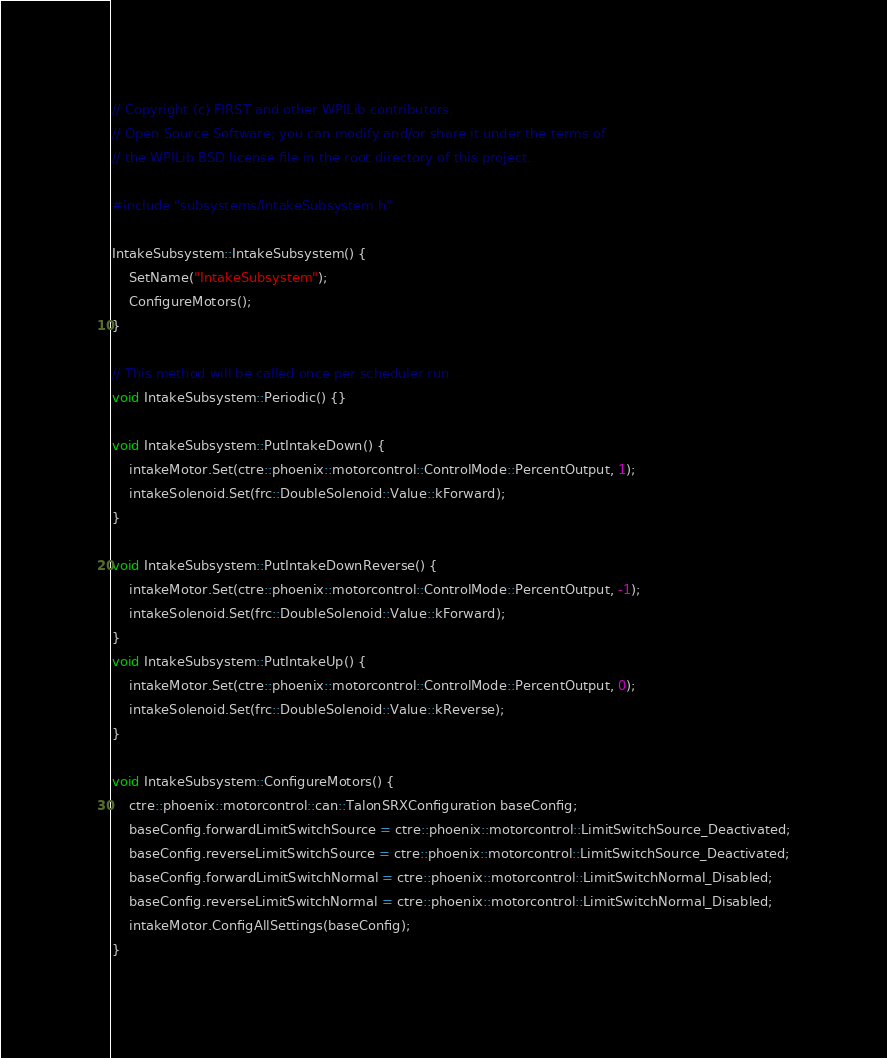Convert code to text. <code><loc_0><loc_0><loc_500><loc_500><_C++_>// Copyright (c) FIRST and other WPILib contributors.
// Open Source Software; you can modify and/or share it under the terms of
// the WPILib BSD license file in the root directory of this project.

#include "subsystems/IntakeSubsystem.h"

IntakeSubsystem::IntakeSubsystem() {
    SetName("IntakeSubsystem");
    ConfigureMotors();
}

// This method will be called once per scheduler run
void IntakeSubsystem::Periodic() {}

void IntakeSubsystem::PutIntakeDown() {
    intakeMotor.Set(ctre::phoenix::motorcontrol::ControlMode::PercentOutput, 1);
    intakeSolenoid.Set(frc::DoubleSolenoid::Value::kForward);
}

void IntakeSubsystem::PutIntakeDownReverse() {
    intakeMotor.Set(ctre::phoenix::motorcontrol::ControlMode::PercentOutput, -1);
    intakeSolenoid.Set(frc::DoubleSolenoid::Value::kForward);
}
void IntakeSubsystem::PutIntakeUp() {
    intakeMotor.Set(ctre::phoenix::motorcontrol::ControlMode::PercentOutput, 0);
    intakeSolenoid.Set(frc::DoubleSolenoid::Value::kReverse);
}

void IntakeSubsystem::ConfigureMotors() {
    ctre::phoenix::motorcontrol::can::TalonSRXConfiguration baseConfig;
    baseConfig.forwardLimitSwitchSource = ctre::phoenix::motorcontrol::LimitSwitchSource_Deactivated;
    baseConfig.reverseLimitSwitchSource = ctre::phoenix::motorcontrol::LimitSwitchSource_Deactivated;
    baseConfig.forwardLimitSwitchNormal = ctre::phoenix::motorcontrol::LimitSwitchNormal_Disabled;
    baseConfig.reverseLimitSwitchNormal = ctre::phoenix::motorcontrol::LimitSwitchNormal_Disabled;
    intakeMotor.ConfigAllSettings(baseConfig);
}
</code> 